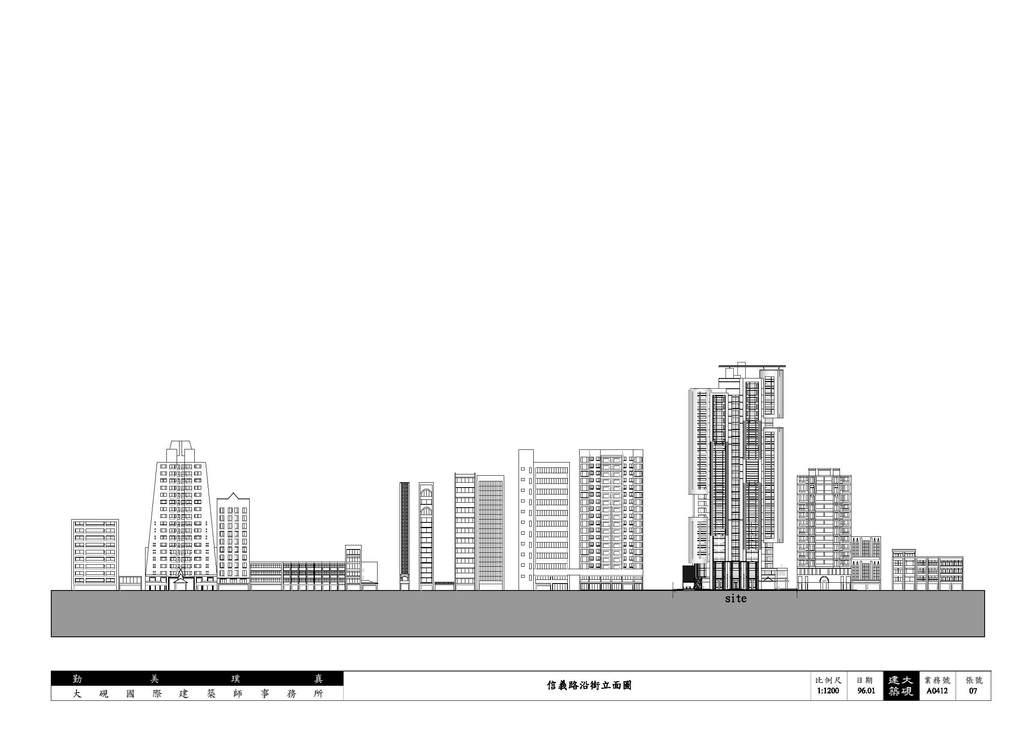What type of drawings are present in the image? There are sketches of buildings in the image. Can you see the pet walking down the alley in the image? There is no pet or alley present in the image; it only contains sketches of buildings. 